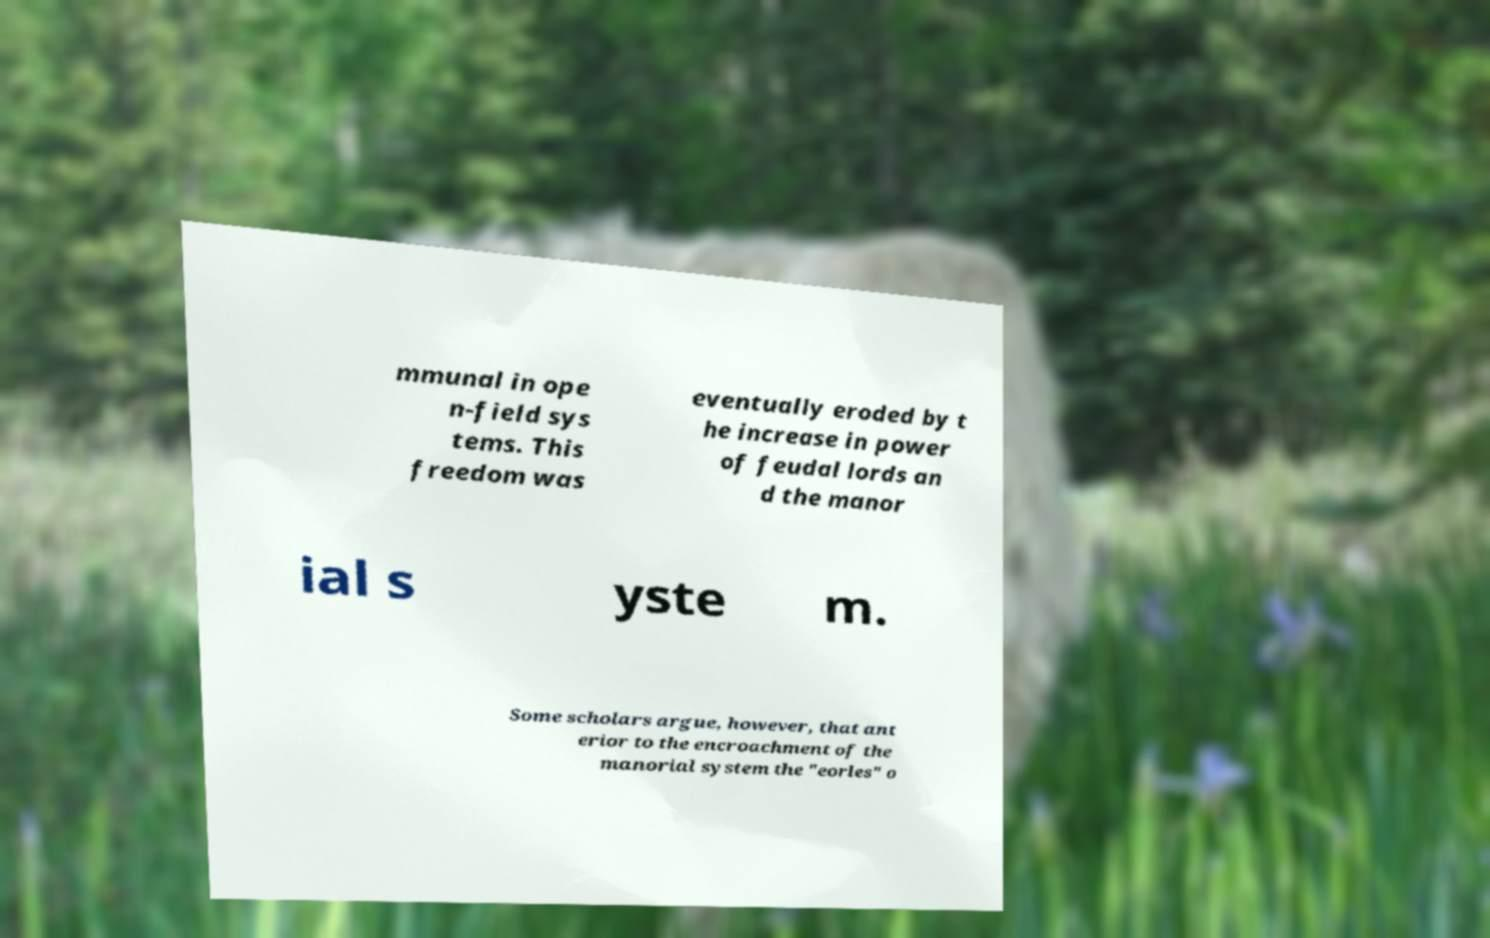Could you assist in decoding the text presented in this image and type it out clearly? mmunal in ope n-field sys tems. This freedom was eventually eroded by t he increase in power of feudal lords an d the manor ial s yste m. Some scholars argue, however, that ant erior to the encroachment of the manorial system the "eorles" o 